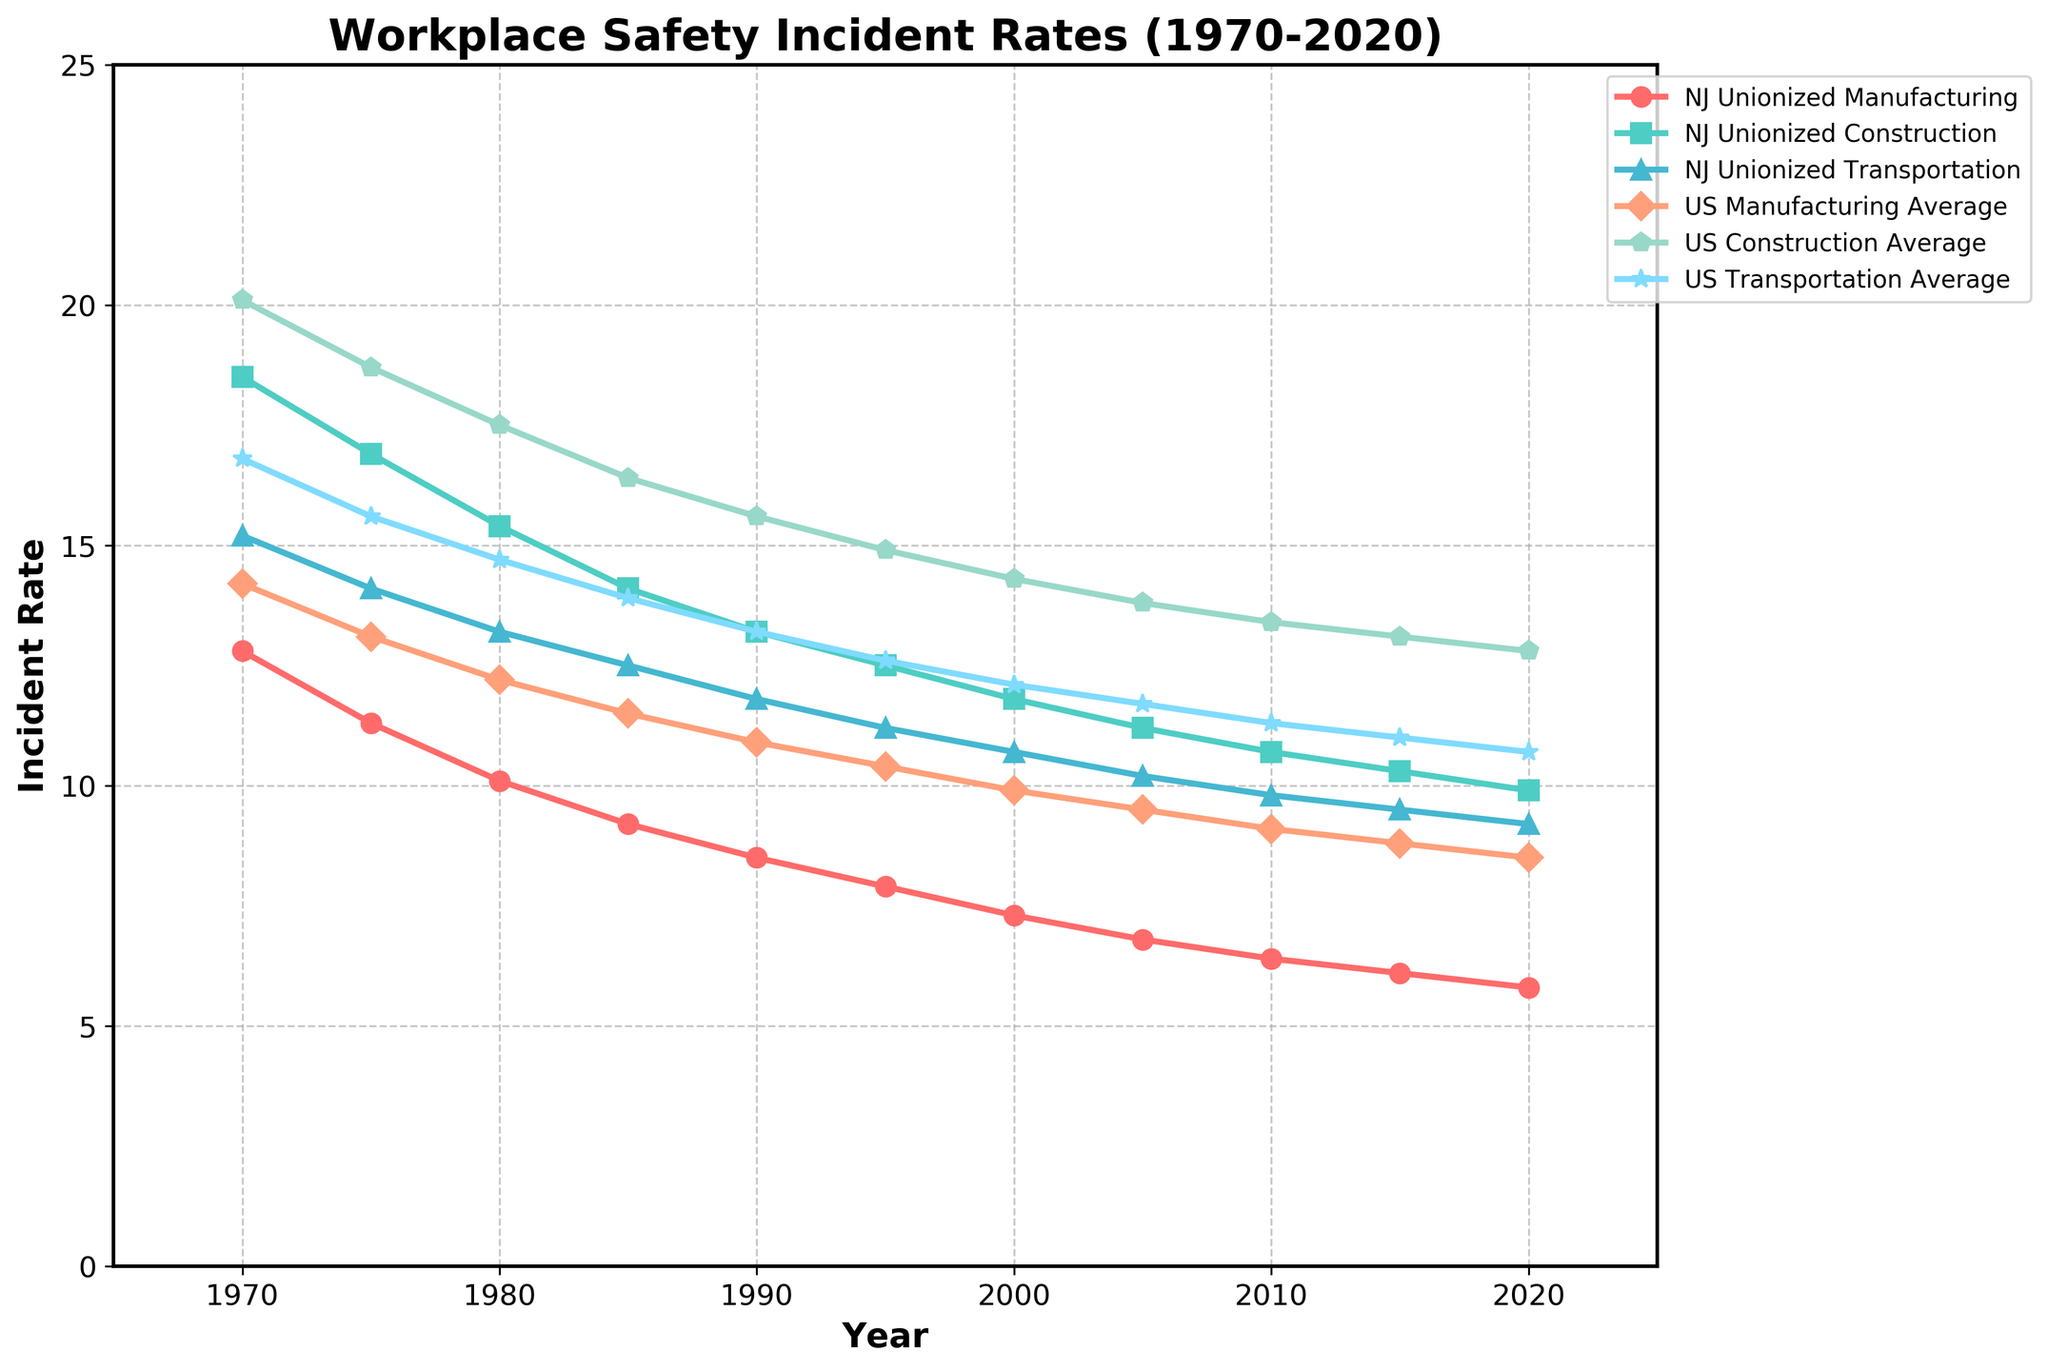What's the incident rate for NJ Unionized Construction in 1995? Locate the line representing NJ Unionized Construction. In 1995, the incident rate is indicated at the point on the line corresponding to the year 1995.
Answer: 12.5 What is the trend in incident rates for NJ Unionized Manufacturing from 1970 to 2020? Observe the line representing NJ Unionized Manufacturing. Notice the decline in the incident rates as you move from 1970 (12.8) to 2020 (5.8).
Answer: Declining How does the incident rate of NJ Unionized Transportation in 2020 compare to the US Transportation Average in 2020? Compare the points for NJ Unionized Transportation and US Transportation Average for the year 2020 on their respective lines. NJ Unionized Transportation is at 9.2, while US Transportation Average is at 10.7.
Answer: Lower In which year does the incident rate for NJ Unionized Manufacturing become lower than 10? Look at the NJ Unionized Manufacturing line and find the year where the incident rate is first below 10. This occurs in 1985 (9.2).
Answer: 1985 What is the average incident rate for NJ Unionized Construction over the decades mentioned (1970-2020)? Sum the incident rates for NJ Unionized Construction for each year and divide by the number of years (10). Sum: 18.5+16.9+15.4+14.1+13.2+12.5+11.8+11.2+10.7+10.3+9.9 = 134.5. Average = 134.5 / 11.
Answer: 12.2 Compare the incident rates in 1970 between NJ Unionized Manufacturing and US Manufacturing Average. Locate the points for the year 1970 for both NJ Unionized Manufacturing (12.8) and US Manufacturing Average (14.2). NJ is lower.
Answer: NJ: 12.8, US: 14.2 Which line has the smallest decrease in incident rates from 1970 to 2020? Calculate the difference between the 1970 and 2020 values for each line and find the smallest. Differences: NJ Manufacturing (12.8-5.8=7), NJ Construction (18.5-9.9=8.6), NJ Transportation (15.2-9.2=6), US Manufacturing (14.2-8.5=5.7), US Construction (20.1-12.8=7.3), US Transportation (16.8-10.7=6.1).
Answer: US Transportation What can you infer about workplace safety trends in unionized industries in NJ compared to national averages? Observe the trends of NJ Unionized industries and compare them with US averages. NJ Unionized industries generally show a steady decline similar to the national averages but often start and remain lower, indicating better workplace safety in NJ.
Answer: NJ shows better safety trends Which industry had the highest incident rate in 1970 in NJ Unionized sectors? Locate the points for 1970 on the NJ Unionized lines and identify the highest. NJ Unionized Construction is highest at 18.5.
Answer: NJ Unionized Construction 